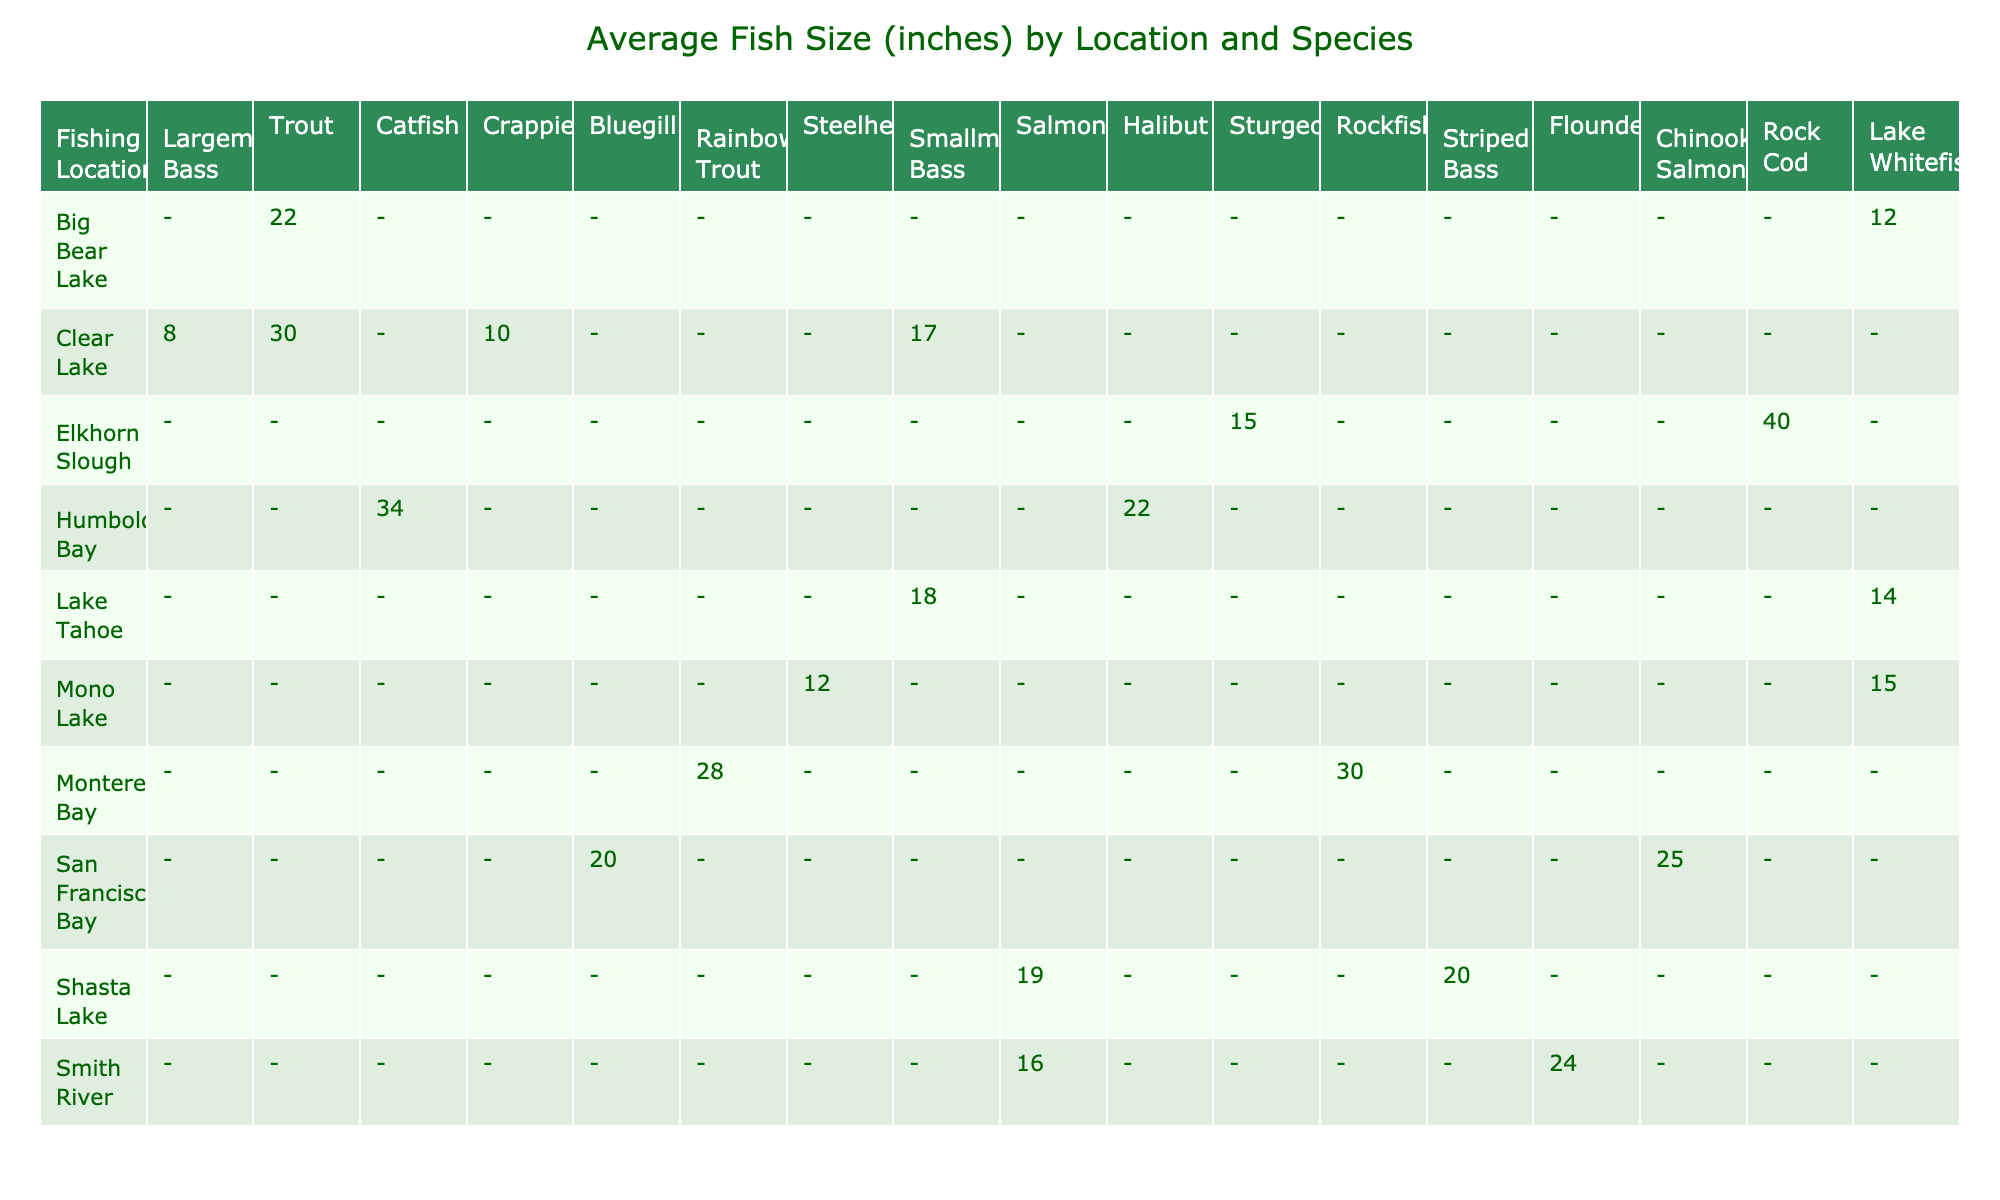What was the largest fish caught, and what species was it? The largest fish caught was a Sturgeon measuring 40 inches, which can be identified by checking the maximum size in the table.
Answer: 40 inches, Sturgeon Which fishing location had the highest average fish size? To determine this, we look at the average fish sizes for all locations in the table; Elkhorn Slough had the highest average fish size of 27.5 inches (average of Sturgeon and Rockfish).
Answer: Elkhorn Slough How many different species of fish were caught at Lake Tahoe? By examining the entries for Lake Tahoe in the table, we find that two species were caught: Largemouth Bass and Trout.
Answer: 2 species What was the average size of the Trout caught in 2023? There are multiple entries for Trout (14 inches at Lake Tahoe, 16 inches at Smith River, 19 inches at Shasta Lake, and 15 inches at Mono Lake). The average size is (14 + 16 + 19 + 15)/4 = 16 inches.
Answer: 16 inches Did Mike catch any fish heavier than 10 lbs? By reviewing the weights of all fish caught by Mike, we find that he caught a Halibut weighing 15 lbs and a Catfish weighing 9 lbs, confirming that he did catch fish over 10 lbs.
Answer: Yes Which fishing trip had the most species caught, and how many? By reviewing the trips and counting the different species from each, the trip on February 10 at Big Bear Lake had two species caught (Catfish and Trout), which is the maximum found in the trips listed.
Answer: Big Bear Lake, 2 species Was there any trip where a person caught more than one species of fish? Looking at the table, we see only one species caught per trip for each individual, indicating that nobody caught more than one species on any single trip.
Answer: No Compare the average sizes of Catfish at Clear Lake and Big Bear Lake. Which one was larger? In the table, Catfish at Clear Lake measured 30 inches on September 15, while at Big Bear Lake they measured 22 inches on February 10. Comparing these averages shows that Clear Lake's Catfish were larger.
Answer: Clear Lake How many inches longer is the largest fish caught in the San Francisco Bay than the smallest fish caught in the same location? Striped Bass in San Francisco Bay measured 25 inches, and Flounder measured 20 inches. The difference is calculated as 25 - 20 = 5 inches longer.
Answer: 5 inches What are the total lengths of all fish caught by John? The fish caught by John were a Largemouth Bass (18 inches), Bluegill (8 inches), Salmon (30 inches), and Catfish (30 inches), summing them gives 18 + 8 + 30 + 30 = 86 inches total.
Answer: 86 inches 